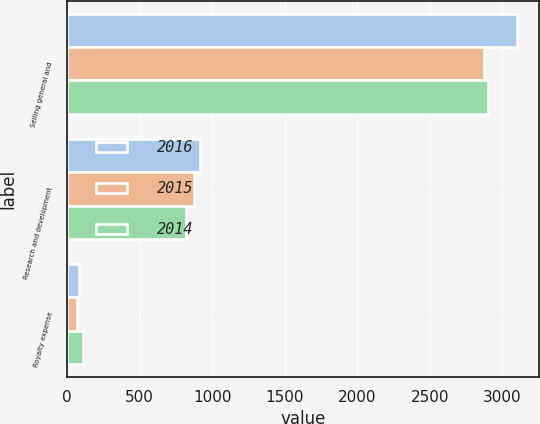<chart> <loc_0><loc_0><loc_500><loc_500><stacked_bar_chart><ecel><fcel>Selling general and<fcel>Research and development<fcel>Royalty expense<nl><fcel>2016<fcel>3099<fcel>920<fcel>79<nl><fcel>2015<fcel>2873<fcel>876<fcel>70<nl><fcel>2014<fcel>2902<fcel>817<fcel>111<nl></chart> 